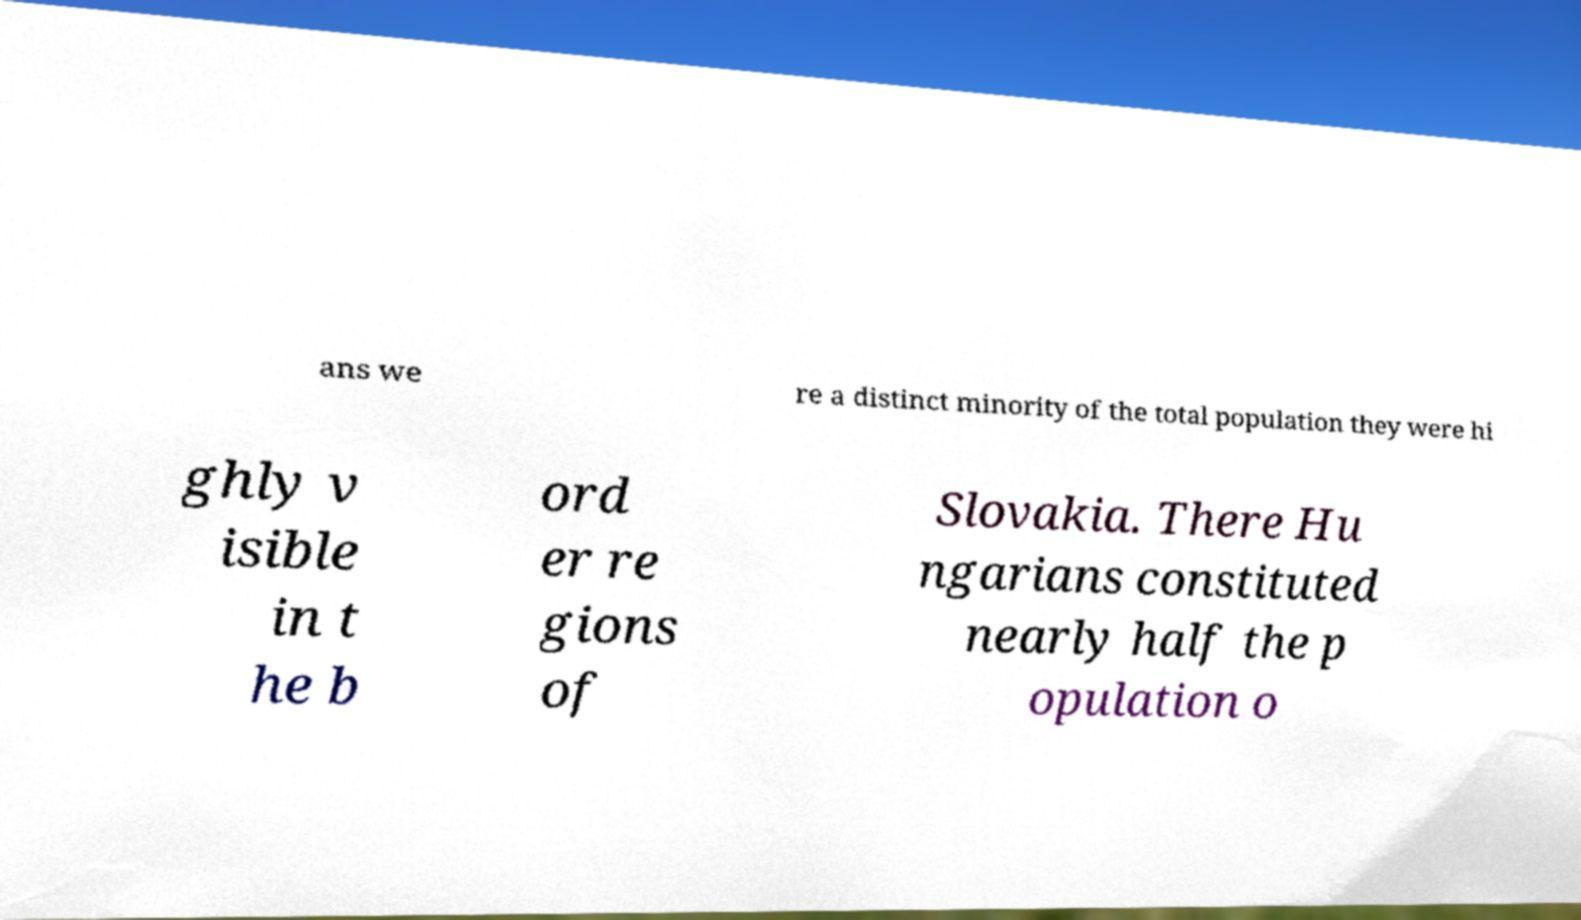Could you assist in decoding the text presented in this image and type it out clearly? ans we re a distinct minority of the total population they were hi ghly v isible in t he b ord er re gions of Slovakia. There Hu ngarians constituted nearly half the p opulation o 